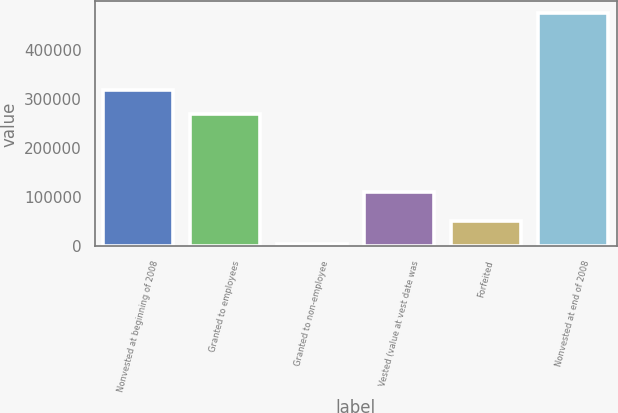Convert chart. <chart><loc_0><loc_0><loc_500><loc_500><bar_chart><fcel>Nonvested at beginning of 2008<fcel>Granted to employees<fcel>Granted to non-employee<fcel>Vested (value at vest date was<fcel>Forfeited<fcel>Nonvested at end of 2008<nl><fcel>319300<fcel>270250<fcel>4800<fcel>110168<fcel>51839.4<fcel>475194<nl></chart> 